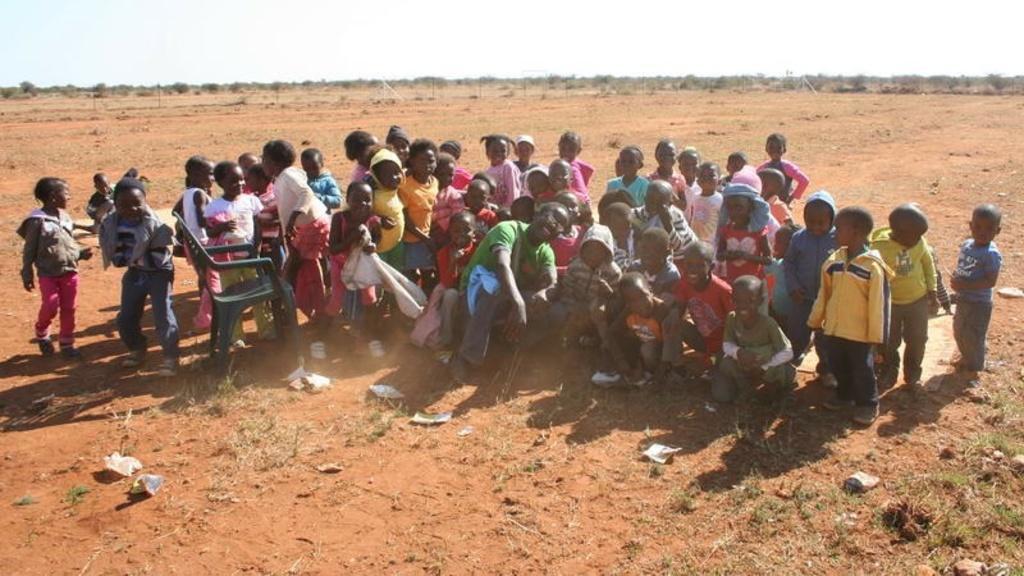Please provide a concise description of this image. In this image I can see group of children. There is a person and there is a chair. There are trees and in the background there is sky. 